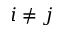Convert formula to latex. <formula><loc_0><loc_0><loc_500><loc_500>i \neq j</formula> 